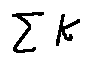<formula> <loc_0><loc_0><loc_500><loc_500>\sum k</formula> 